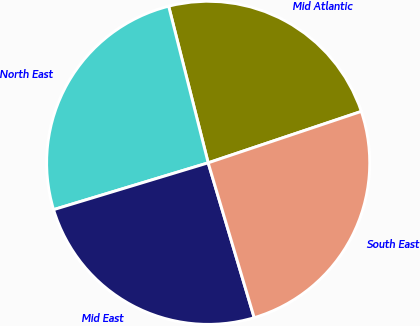Convert chart. <chart><loc_0><loc_0><loc_500><loc_500><pie_chart><fcel>Mid Atlantic<fcel>North East<fcel>Mid East<fcel>South East<nl><fcel>23.78%<fcel>25.75%<fcel>24.92%<fcel>25.56%<nl></chart> 